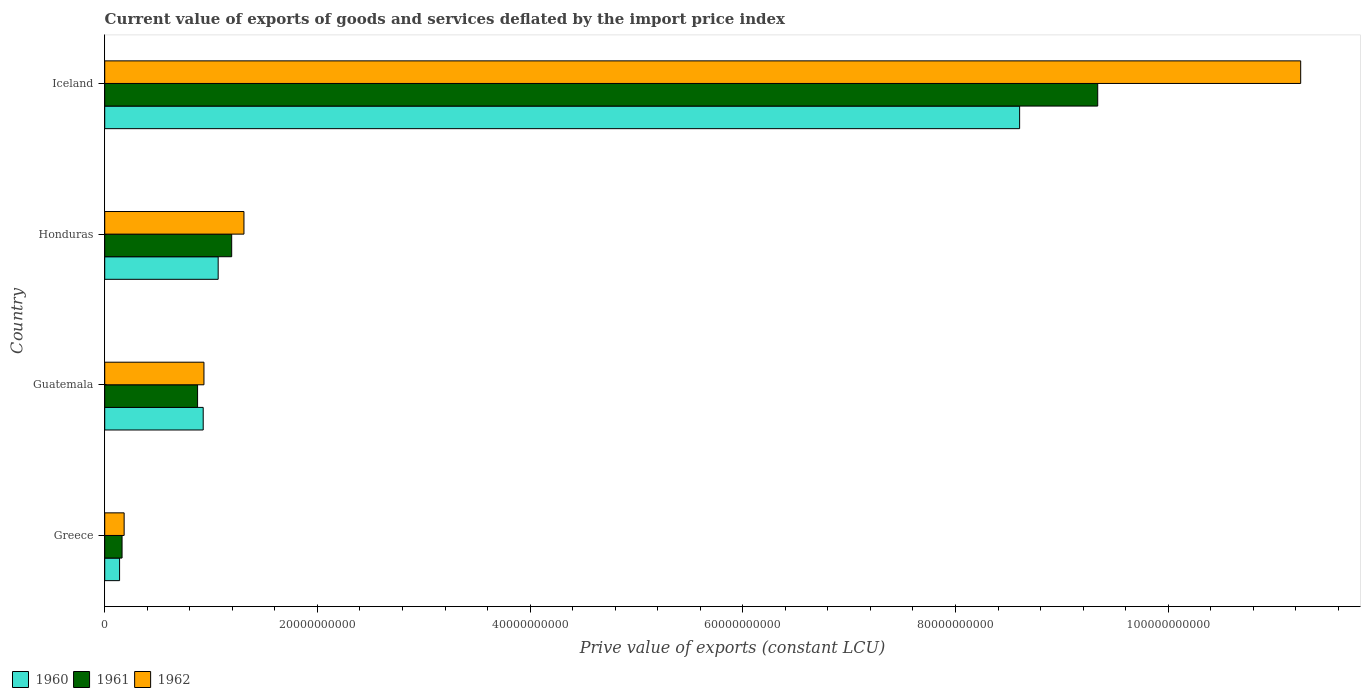How many bars are there on the 2nd tick from the top?
Provide a short and direct response. 3. How many bars are there on the 4th tick from the bottom?
Your answer should be compact. 3. What is the label of the 1st group of bars from the top?
Ensure brevity in your answer.  Iceland. In how many cases, is the number of bars for a given country not equal to the number of legend labels?
Make the answer very short. 0. What is the prive value of exports in 1960 in Honduras?
Offer a terse response. 1.07e+1. Across all countries, what is the maximum prive value of exports in 1960?
Your answer should be very brief. 8.60e+1. Across all countries, what is the minimum prive value of exports in 1961?
Provide a short and direct response. 1.63e+09. In which country was the prive value of exports in 1961 maximum?
Your answer should be compact. Iceland. In which country was the prive value of exports in 1962 minimum?
Make the answer very short. Greece. What is the total prive value of exports in 1960 in the graph?
Your answer should be very brief. 1.07e+11. What is the difference between the prive value of exports in 1960 in Guatemala and that in Iceland?
Offer a terse response. -7.68e+1. What is the difference between the prive value of exports in 1962 in Greece and the prive value of exports in 1960 in Iceland?
Ensure brevity in your answer.  -8.42e+1. What is the average prive value of exports in 1962 per country?
Keep it short and to the point. 3.42e+1. What is the difference between the prive value of exports in 1961 and prive value of exports in 1960 in Greece?
Provide a succinct answer. 2.34e+08. What is the ratio of the prive value of exports in 1960 in Greece to that in Honduras?
Ensure brevity in your answer.  0.13. Is the prive value of exports in 1961 in Honduras less than that in Iceland?
Offer a very short reply. Yes. Is the difference between the prive value of exports in 1961 in Guatemala and Honduras greater than the difference between the prive value of exports in 1960 in Guatemala and Honduras?
Make the answer very short. No. What is the difference between the highest and the second highest prive value of exports in 1960?
Provide a succinct answer. 7.54e+1. What is the difference between the highest and the lowest prive value of exports in 1961?
Ensure brevity in your answer.  9.17e+1. Is the sum of the prive value of exports in 1962 in Greece and Honduras greater than the maximum prive value of exports in 1961 across all countries?
Give a very brief answer. No. What does the 3rd bar from the bottom in Iceland represents?
Provide a short and direct response. 1962. How many bars are there?
Offer a very short reply. 12. Are all the bars in the graph horizontal?
Your answer should be very brief. Yes. How many countries are there in the graph?
Ensure brevity in your answer.  4. Does the graph contain any zero values?
Offer a very short reply. No. Does the graph contain grids?
Your response must be concise. No. Where does the legend appear in the graph?
Provide a short and direct response. Bottom left. How many legend labels are there?
Your answer should be very brief. 3. How are the legend labels stacked?
Offer a very short reply. Horizontal. What is the title of the graph?
Your answer should be very brief. Current value of exports of goods and services deflated by the import price index. What is the label or title of the X-axis?
Your response must be concise. Prive value of exports (constant LCU). What is the label or title of the Y-axis?
Your answer should be very brief. Country. What is the Prive value of exports (constant LCU) of 1960 in Greece?
Your response must be concise. 1.40e+09. What is the Prive value of exports (constant LCU) of 1961 in Greece?
Your answer should be very brief. 1.63e+09. What is the Prive value of exports (constant LCU) in 1962 in Greece?
Offer a very short reply. 1.83e+09. What is the Prive value of exports (constant LCU) of 1960 in Guatemala?
Keep it short and to the point. 9.26e+09. What is the Prive value of exports (constant LCU) of 1961 in Guatemala?
Give a very brief answer. 8.73e+09. What is the Prive value of exports (constant LCU) of 1962 in Guatemala?
Offer a very short reply. 9.33e+09. What is the Prive value of exports (constant LCU) of 1960 in Honduras?
Make the answer very short. 1.07e+1. What is the Prive value of exports (constant LCU) in 1961 in Honduras?
Make the answer very short. 1.19e+1. What is the Prive value of exports (constant LCU) of 1962 in Honduras?
Provide a short and direct response. 1.31e+1. What is the Prive value of exports (constant LCU) in 1960 in Iceland?
Make the answer very short. 8.60e+1. What is the Prive value of exports (constant LCU) in 1961 in Iceland?
Provide a succinct answer. 9.34e+1. What is the Prive value of exports (constant LCU) in 1962 in Iceland?
Provide a succinct answer. 1.12e+11. Across all countries, what is the maximum Prive value of exports (constant LCU) in 1960?
Your answer should be compact. 8.60e+1. Across all countries, what is the maximum Prive value of exports (constant LCU) in 1961?
Provide a succinct answer. 9.34e+1. Across all countries, what is the maximum Prive value of exports (constant LCU) in 1962?
Keep it short and to the point. 1.12e+11. Across all countries, what is the minimum Prive value of exports (constant LCU) of 1960?
Your answer should be very brief. 1.40e+09. Across all countries, what is the minimum Prive value of exports (constant LCU) of 1961?
Your response must be concise. 1.63e+09. Across all countries, what is the minimum Prive value of exports (constant LCU) of 1962?
Offer a very short reply. 1.83e+09. What is the total Prive value of exports (constant LCU) in 1960 in the graph?
Your response must be concise. 1.07e+11. What is the total Prive value of exports (constant LCU) of 1961 in the graph?
Give a very brief answer. 1.16e+11. What is the total Prive value of exports (constant LCU) of 1962 in the graph?
Your response must be concise. 1.37e+11. What is the difference between the Prive value of exports (constant LCU) in 1960 in Greece and that in Guatemala?
Your answer should be very brief. -7.86e+09. What is the difference between the Prive value of exports (constant LCU) in 1961 in Greece and that in Guatemala?
Ensure brevity in your answer.  -7.10e+09. What is the difference between the Prive value of exports (constant LCU) in 1962 in Greece and that in Guatemala?
Offer a very short reply. -7.51e+09. What is the difference between the Prive value of exports (constant LCU) in 1960 in Greece and that in Honduras?
Your answer should be very brief. -9.27e+09. What is the difference between the Prive value of exports (constant LCU) in 1961 in Greece and that in Honduras?
Give a very brief answer. -1.03e+1. What is the difference between the Prive value of exports (constant LCU) in 1962 in Greece and that in Honduras?
Offer a very short reply. -1.13e+1. What is the difference between the Prive value of exports (constant LCU) in 1960 in Greece and that in Iceland?
Provide a succinct answer. -8.46e+1. What is the difference between the Prive value of exports (constant LCU) of 1961 in Greece and that in Iceland?
Provide a short and direct response. -9.17e+1. What is the difference between the Prive value of exports (constant LCU) in 1962 in Greece and that in Iceland?
Make the answer very short. -1.11e+11. What is the difference between the Prive value of exports (constant LCU) of 1960 in Guatemala and that in Honduras?
Provide a short and direct response. -1.41e+09. What is the difference between the Prive value of exports (constant LCU) in 1961 in Guatemala and that in Honduras?
Provide a succinct answer. -3.21e+09. What is the difference between the Prive value of exports (constant LCU) in 1962 in Guatemala and that in Honduras?
Your response must be concise. -3.76e+09. What is the difference between the Prive value of exports (constant LCU) in 1960 in Guatemala and that in Iceland?
Provide a short and direct response. -7.68e+1. What is the difference between the Prive value of exports (constant LCU) in 1961 in Guatemala and that in Iceland?
Provide a succinct answer. -8.46e+1. What is the difference between the Prive value of exports (constant LCU) of 1962 in Guatemala and that in Iceland?
Give a very brief answer. -1.03e+11. What is the difference between the Prive value of exports (constant LCU) of 1960 in Honduras and that in Iceland?
Your answer should be very brief. -7.54e+1. What is the difference between the Prive value of exports (constant LCU) in 1961 in Honduras and that in Iceland?
Your response must be concise. -8.14e+1. What is the difference between the Prive value of exports (constant LCU) in 1962 in Honduras and that in Iceland?
Give a very brief answer. -9.94e+1. What is the difference between the Prive value of exports (constant LCU) of 1960 in Greece and the Prive value of exports (constant LCU) of 1961 in Guatemala?
Ensure brevity in your answer.  -7.34e+09. What is the difference between the Prive value of exports (constant LCU) of 1960 in Greece and the Prive value of exports (constant LCU) of 1962 in Guatemala?
Offer a very short reply. -7.93e+09. What is the difference between the Prive value of exports (constant LCU) in 1961 in Greece and the Prive value of exports (constant LCU) in 1962 in Guatemala?
Ensure brevity in your answer.  -7.70e+09. What is the difference between the Prive value of exports (constant LCU) in 1960 in Greece and the Prive value of exports (constant LCU) in 1961 in Honduras?
Your response must be concise. -1.05e+1. What is the difference between the Prive value of exports (constant LCU) in 1960 in Greece and the Prive value of exports (constant LCU) in 1962 in Honduras?
Your answer should be compact. -1.17e+1. What is the difference between the Prive value of exports (constant LCU) of 1961 in Greece and the Prive value of exports (constant LCU) of 1962 in Honduras?
Offer a very short reply. -1.15e+1. What is the difference between the Prive value of exports (constant LCU) of 1960 in Greece and the Prive value of exports (constant LCU) of 1961 in Iceland?
Offer a very short reply. -9.20e+1. What is the difference between the Prive value of exports (constant LCU) in 1960 in Greece and the Prive value of exports (constant LCU) in 1962 in Iceland?
Make the answer very short. -1.11e+11. What is the difference between the Prive value of exports (constant LCU) of 1961 in Greece and the Prive value of exports (constant LCU) of 1962 in Iceland?
Your response must be concise. -1.11e+11. What is the difference between the Prive value of exports (constant LCU) in 1960 in Guatemala and the Prive value of exports (constant LCU) in 1961 in Honduras?
Keep it short and to the point. -2.68e+09. What is the difference between the Prive value of exports (constant LCU) of 1960 in Guatemala and the Prive value of exports (constant LCU) of 1962 in Honduras?
Offer a terse response. -3.83e+09. What is the difference between the Prive value of exports (constant LCU) in 1961 in Guatemala and the Prive value of exports (constant LCU) in 1962 in Honduras?
Offer a terse response. -4.36e+09. What is the difference between the Prive value of exports (constant LCU) of 1960 in Guatemala and the Prive value of exports (constant LCU) of 1961 in Iceland?
Your response must be concise. -8.41e+1. What is the difference between the Prive value of exports (constant LCU) in 1960 in Guatemala and the Prive value of exports (constant LCU) in 1962 in Iceland?
Your answer should be compact. -1.03e+11. What is the difference between the Prive value of exports (constant LCU) in 1961 in Guatemala and the Prive value of exports (constant LCU) in 1962 in Iceland?
Make the answer very short. -1.04e+11. What is the difference between the Prive value of exports (constant LCU) in 1960 in Honduras and the Prive value of exports (constant LCU) in 1961 in Iceland?
Provide a short and direct response. -8.27e+1. What is the difference between the Prive value of exports (constant LCU) in 1960 in Honduras and the Prive value of exports (constant LCU) in 1962 in Iceland?
Keep it short and to the point. -1.02e+11. What is the difference between the Prive value of exports (constant LCU) in 1961 in Honduras and the Prive value of exports (constant LCU) in 1962 in Iceland?
Keep it short and to the point. -1.01e+11. What is the average Prive value of exports (constant LCU) in 1960 per country?
Make the answer very short. 2.68e+1. What is the average Prive value of exports (constant LCU) of 1961 per country?
Give a very brief answer. 2.89e+1. What is the average Prive value of exports (constant LCU) of 1962 per country?
Make the answer very short. 3.42e+1. What is the difference between the Prive value of exports (constant LCU) in 1960 and Prive value of exports (constant LCU) in 1961 in Greece?
Keep it short and to the point. -2.34e+08. What is the difference between the Prive value of exports (constant LCU) in 1960 and Prive value of exports (constant LCU) in 1962 in Greece?
Provide a short and direct response. -4.29e+08. What is the difference between the Prive value of exports (constant LCU) of 1961 and Prive value of exports (constant LCU) of 1962 in Greece?
Your answer should be compact. -1.95e+08. What is the difference between the Prive value of exports (constant LCU) in 1960 and Prive value of exports (constant LCU) in 1961 in Guatemala?
Give a very brief answer. 5.29e+08. What is the difference between the Prive value of exports (constant LCU) of 1960 and Prive value of exports (constant LCU) of 1962 in Guatemala?
Your answer should be very brief. -7.00e+07. What is the difference between the Prive value of exports (constant LCU) of 1961 and Prive value of exports (constant LCU) of 1962 in Guatemala?
Your answer should be compact. -5.99e+08. What is the difference between the Prive value of exports (constant LCU) in 1960 and Prive value of exports (constant LCU) in 1961 in Honduras?
Make the answer very short. -1.27e+09. What is the difference between the Prive value of exports (constant LCU) of 1960 and Prive value of exports (constant LCU) of 1962 in Honduras?
Offer a terse response. -2.43e+09. What is the difference between the Prive value of exports (constant LCU) of 1961 and Prive value of exports (constant LCU) of 1962 in Honduras?
Your answer should be compact. -1.15e+09. What is the difference between the Prive value of exports (constant LCU) of 1960 and Prive value of exports (constant LCU) of 1961 in Iceland?
Your answer should be compact. -7.34e+09. What is the difference between the Prive value of exports (constant LCU) in 1960 and Prive value of exports (constant LCU) in 1962 in Iceland?
Offer a terse response. -2.64e+1. What is the difference between the Prive value of exports (constant LCU) in 1961 and Prive value of exports (constant LCU) in 1962 in Iceland?
Make the answer very short. -1.91e+1. What is the ratio of the Prive value of exports (constant LCU) in 1960 in Greece to that in Guatemala?
Give a very brief answer. 0.15. What is the ratio of the Prive value of exports (constant LCU) of 1961 in Greece to that in Guatemala?
Make the answer very short. 0.19. What is the ratio of the Prive value of exports (constant LCU) in 1962 in Greece to that in Guatemala?
Your answer should be compact. 0.2. What is the ratio of the Prive value of exports (constant LCU) in 1960 in Greece to that in Honduras?
Offer a very short reply. 0.13. What is the ratio of the Prive value of exports (constant LCU) in 1961 in Greece to that in Honduras?
Your response must be concise. 0.14. What is the ratio of the Prive value of exports (constant LCU) in 1962 in Greece to that in Honduras?
Provide a succinct answer. 0.14. What is the ratio of the Prive value of exports (constant LCU) of 1960 in Greece to that in Iceland?
Make the answer very short. 0.02. What is the ratio of the Prive value of exports (constant LCU) of 1961 in Greece to that in Iceland?
Keep it short and to the point. 0.02. What is the ratio of the Prive value of exports (constant LCU) in 1962 in Greece to that in Iceland?
Your response must be concise. 0.02. What is the ratio of the Prive value of exports (constant LCU) of 1960 in Guatemala to that in Honduras?
Offer a terse response. 0.87. What is the ratio of the Prive value of exports (constant LCU) in 1961 in Guatemala to that in Honduras?
Your answer should be very brief. 0.73. What is the ratio of the Prive value of exports (constant LCU) in 1962 in Guatemala to that in Honduras?
Provide a succinct answer. 0.71. What is the ratio of the Prive value of exports (constant LCU) of 1960 in Guatemala to that in Iceland?
Your answer should be compact. 0.11. What is the ratio of the Prive value of exports (constant LCU) of 1961 in Guatemala to that in Iceland?
Provide a succinct answer. 0.09. What is the ratio of the Prive value of exports (constant LCU) of 1962 in Guatemala to that in Iceland?
Your answer should be compact. 0.08. What is the ratio of the Prive value of exports (constant LCU) in 1960 in Honduras to that in Iceland?
Provide a short and direct response. 0.12. What is the ratio of the Prive value of exports (constant LCU) of 1961 in Honduras to that in Iceland?
Your answer should be very brief. 0.13. What is the ratio of the Prive value of exports (constant LCU) of 1962 in Honduras to that in Iceland?
Your answer should be compact. 0.12. What is the difference between the highest and the second highest Prive value of exports (constant LCU) in 1960?
Your answer should be very brief. 7.54e+1. What is the difference between the highest and the second highest Prive value of exports (constant LCU) in 1961?
Keep it short and to the point. 8.14e+1. What is the difference between the highest and the second highest Prive value of exports (constant LCU) of 1962?
Give a very brief answer. 9.94e+1. What is the difference between the highest and the lowest Prive value of exports (constant LCU) in 1960?
Ensure brevity in your answer.  8.46e+1. What is the difference between the highest and the lowest Prive value of exports (constant LCU) of 1961?
Provide a short and direct response. 9.17e+1. What is the difference between the highest and the lowest Prive value of exports (constant LCU) of 1962?
Provide a succinct answer. 1.11e+11. 